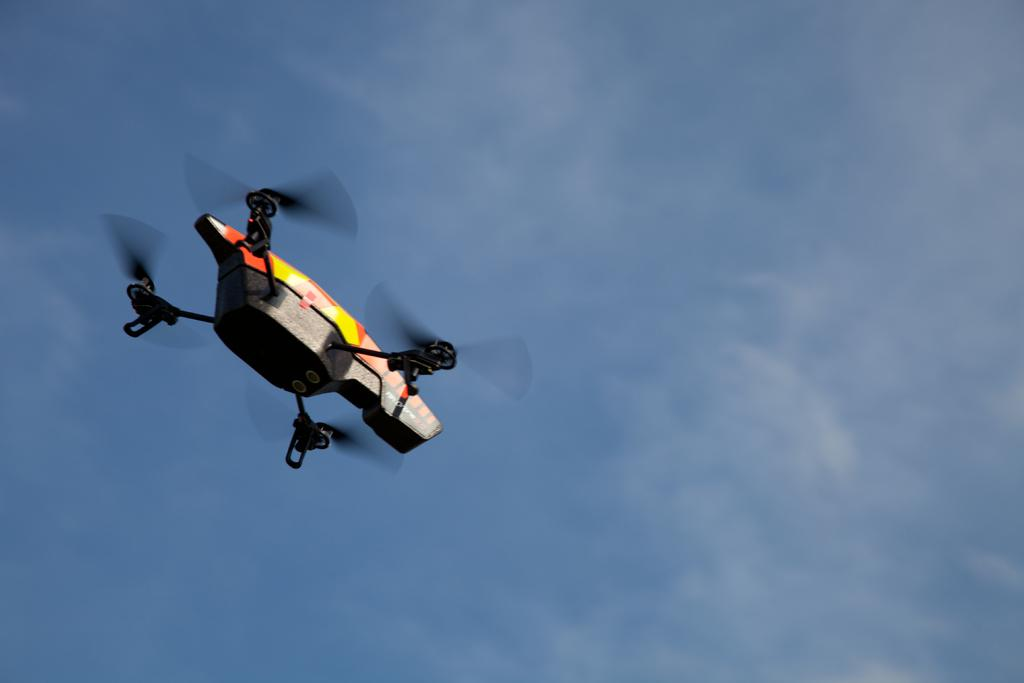What is the main subject of the image? The main subject of the image is a drone. Can you describe the position of the drone in the image? The drone is in the air in the image. What can be seen in the background of the image? There are clouds and the sky visible in the background of the image. How far away is the box from the drone in the image? There is no box present in the image, so it is not possible to determine the distance between a box and the drone. 